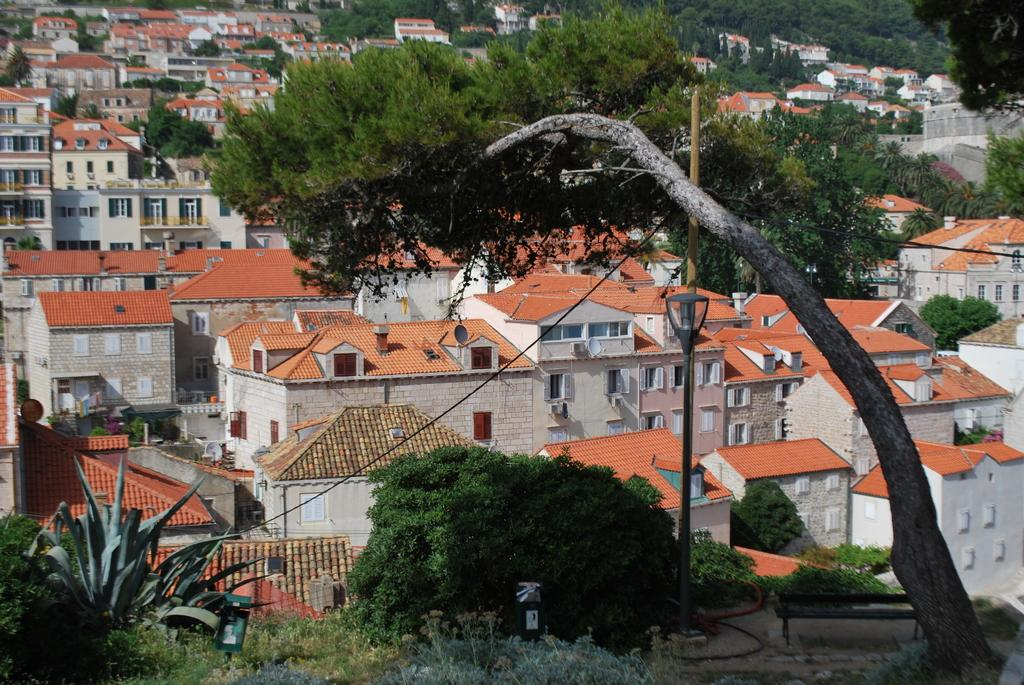What type of structures can be seen in the image? There are buildings in the image. What other natural elements are present in the image? There are trees in the image. What features can be observed on the buildings? The buildings have windows and doors. How many legs does the father have in the image? There is no father or any person present in the image; it only features buildings and trees. 